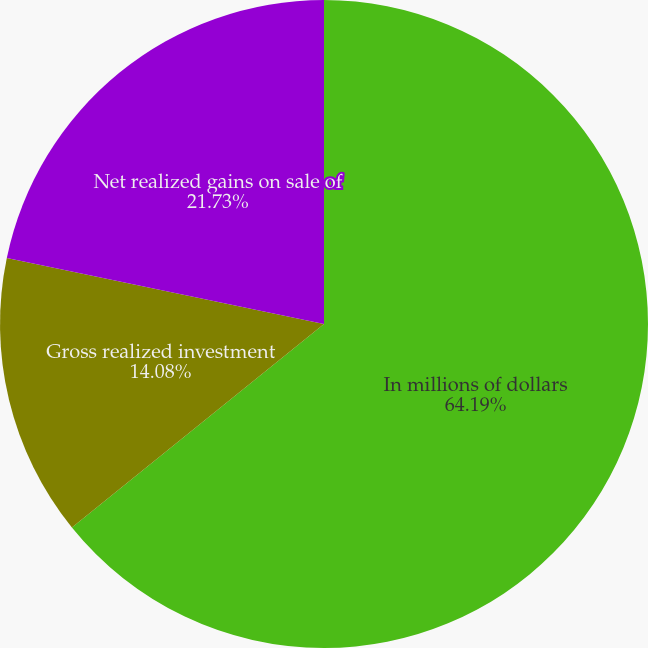<chart> <loc_0><loc_0><loc_500><loc_500><pie_chart><fcel>In millions of dollars<fcel>Gross realized investment<fcel>Net realized gains on sale of<nl><fcel>64.19%<fcel>14.08%<fcel>21.73%<nl></chart> 